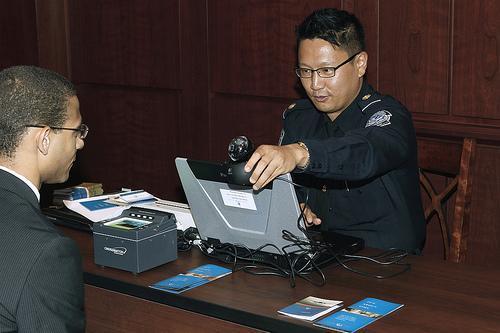How many people are in the photo?
Give a very brief answer. 2. 